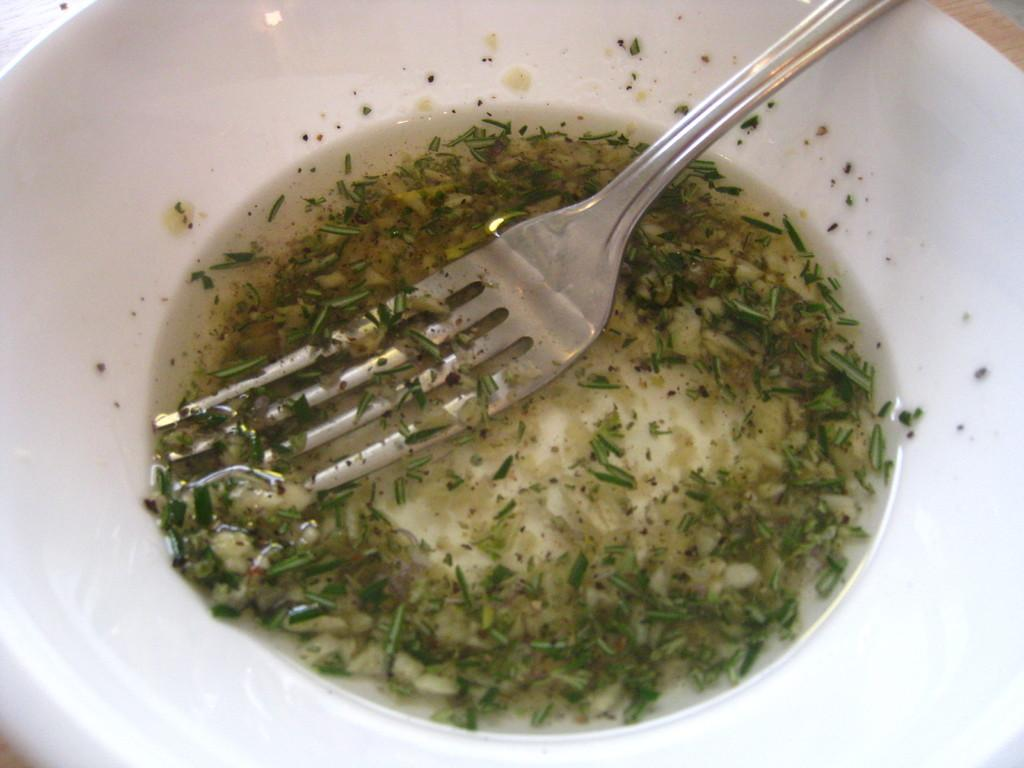What is in the bowl that is visible in the image? There is soup in a bowl in the image. What utensil is in the bowl in the image? There is a fork in the bowl in the image. What is the bowl resting on in the image? The bowl is on an object in the image. What type of rice can be seen in the image? There is no rice present in the image; it features soup in a bowl with a fork. 